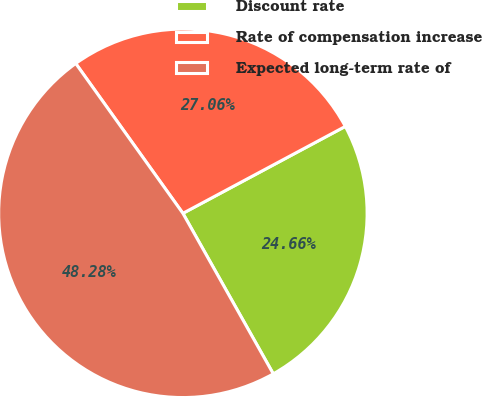Convert chart. <chart><loc_0><loc_0><loc_500><loc_500><pie_chart><fcel>Discount rate<fcel>Rate of compensation increase<fcel>Expected long-term rate of<nl><fcel>24.66%<fcel>27.06%<fcel>48.28%<nl></chart> 